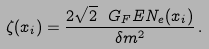<formula> <loc_0><loc_0><loc_500><loc_500>\zeta ( x _ { i } ) = \frac { 2 \sqrt { 2 } \ G _ { F } E N _ { e } ( x _ { i } ) } { \delta m ^ { 2 } } \, .</formula> 